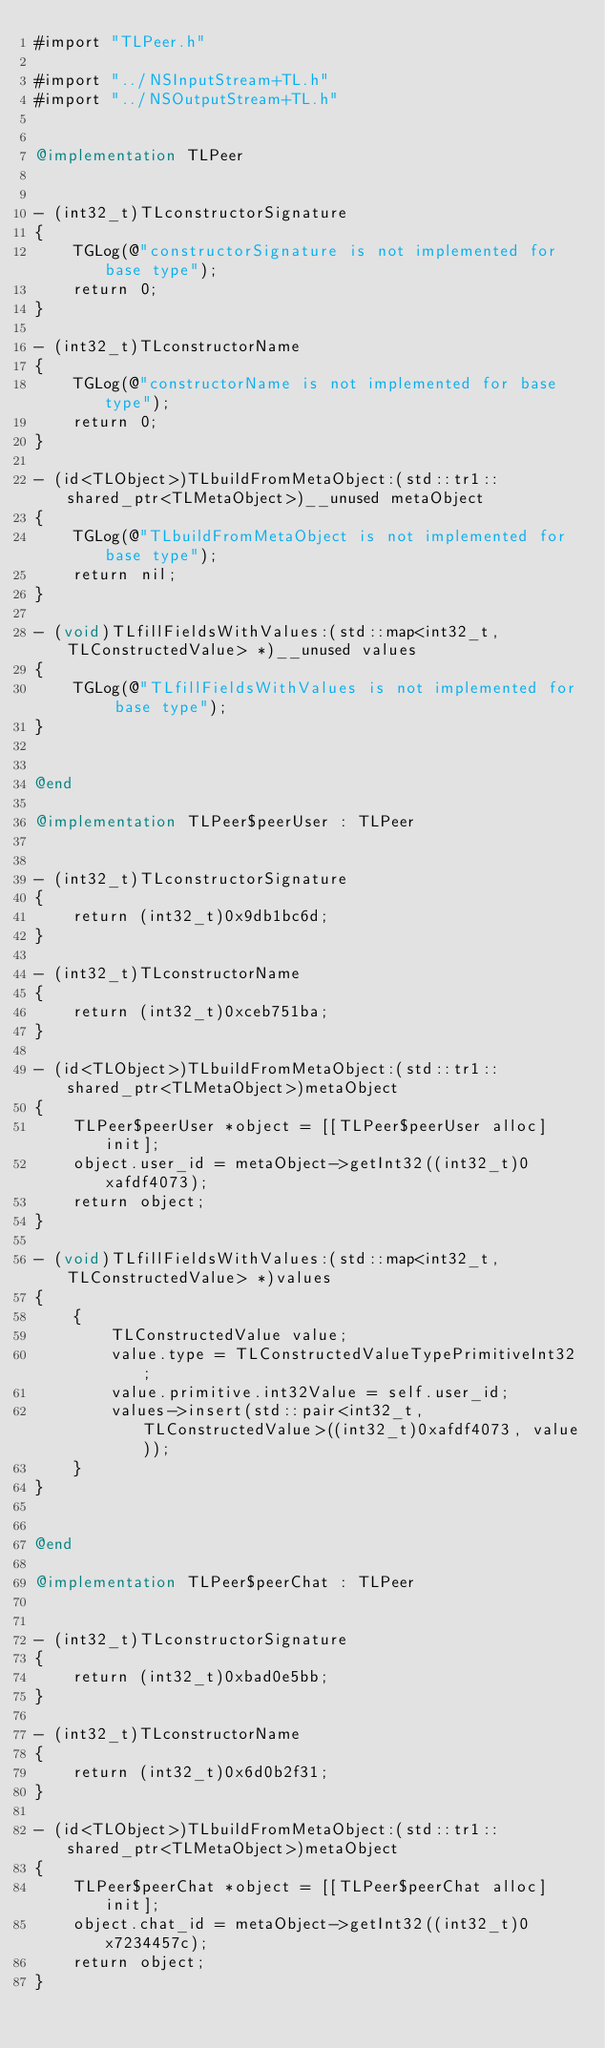Convert code to text. <code><loc_0><loc_0><loc_500><loc_500><_ObjectiveC_>#import "TLPeer.h"

#import "../NSInputStream+TL.h"
#import "../NSOutputStream+TL.h"


@implementation TLPeer


- (int32_t)TLconstructorSignature
{
    TGLog(@"constructorSignature is not implemented for base type");
    return 0;
}

- (int32_t)TLconstructorName
{
    TGLog(@"constructorName is not implemented for base type");
    return 0;
}

- (id<TLObject>)TLbuildFromMetaObject:(std::tr1::shared_ptr<TLMetaObject>)__unused metaObject
{
    TGLog(@"TLbuildFromMetaObject is not implemented for base type");
    return nil;
}

- (void)TLfillFieldsWithValues:(std::map<int32_t, TLConstructedValue> *)__unused values
{
    TGLog(@"TLfillFieldsWithValues is not implemented for base type");
}


@end

@implementation TLPeer$peerUser : TLPeer


- (int32_t)TLconstructorSignature
{
    return (int32_t)0x9db1bc6d;
}

- (int32_t)TLconstructorName
{
    return (int32_t)0xceb751ba;
}

- (id<TLObject>)TLbuildFromMetaObject:(std::tr1::shared_ptr<TLMetaObject>)metaObject
{
    TLPeer$peerUser *object = [[TLPeer$peerUser alloc] init];
    object.user_id = metaObject->getInt32((int32_t)0xafdf4073);
    return object;
}

- (void)TLfillFieldsWithValues:(std::map<int32_t, TLConstructedValue> *)values
{
    {
        TLConstructedValue value;
        value.type = TLConstructedValueTypePrimitiveInt32;
        value.primitive.int32Value = self.user_id;
        values->insert(std::pair<int32_t, TLConstructedValue>((int32_t)0xafdf4073, value));
    }
}


@end

@implementation TLPeer$peerChat : TLPeer


- (int32_t)TLconstructorSignature
{
    return (int32_t)0xbad0e5bb;
}

- (int32_t)TLconstructorName
{
    return (int32_t)0x6d0b2f31;
}

- (id<TLObject>)TLbuildFromMetaObject:(std::tr1::shared_ptr<TLMetaObject>)metaObject
{
    TLPeer$peerChat *object = [[TLPeer$peerChat alloc] init];
    object.chat_id = metaObject->getInt32((int32_t)0x7234457c);
    return object;
}
</code> 